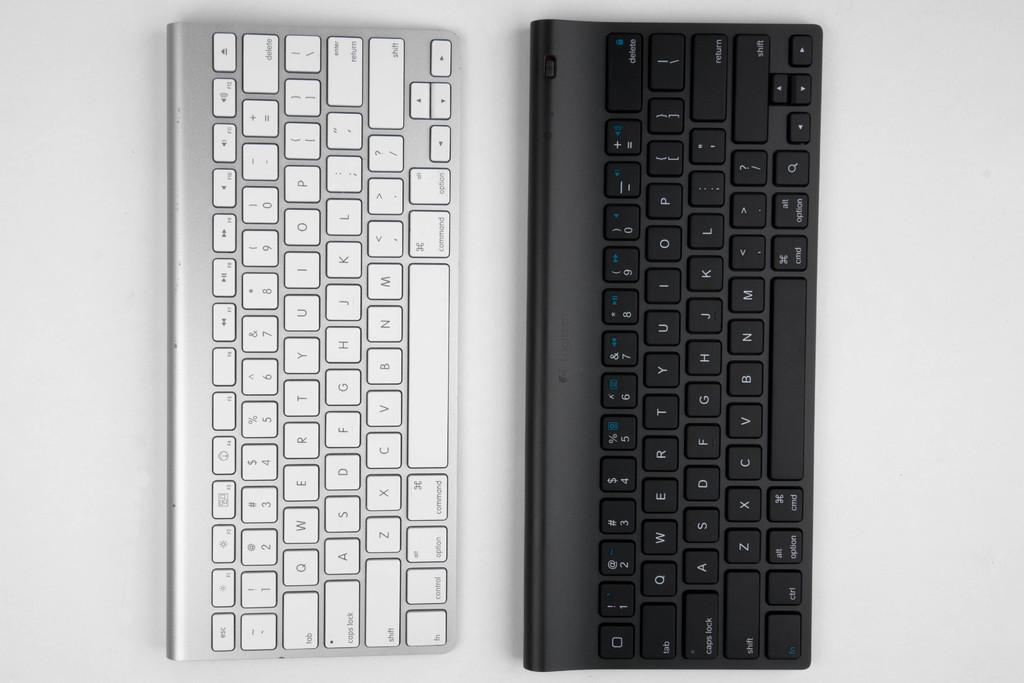Provide a one-sentence caption for the provided image. a silver keyboard is laying beside a black keyboard; both with the basic letters and enter function keys. 